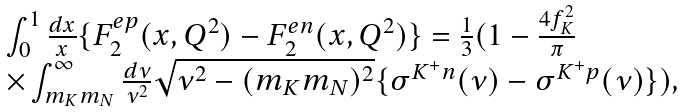Convert formula to latex. <formula><loc_0><loc_0><loc_500><loc_500>\begin{array} { l } \int ^ { 1 } _ { 0 } \frac { d x } { x } \{ F _ { 2 } ^ { e p } ( x , Q ^ { 2 } ) - F _ { 2 } ^ { e n } ( x , Q ^ { 2 } ) \} = \frac { 1 } { 3 } ( 1 - \frac { 4 f _ { K } ^ { 2 } } { \pi } \\ \times \int _ { m _ { K } m _ { N } } ^ { \infty } \frac { d \nu } { \nu ^ { 2 } } \sqrt { \nu ^ { 2 } - ( m _ { K } m _ { N } ) ^ { 2 } } \{ \sigma ^ { K ^ { + } n } ( \nu ) - \sigma ^ { K ^ { + } p } ( \nu ) \} ) , \end{array}</formula> 